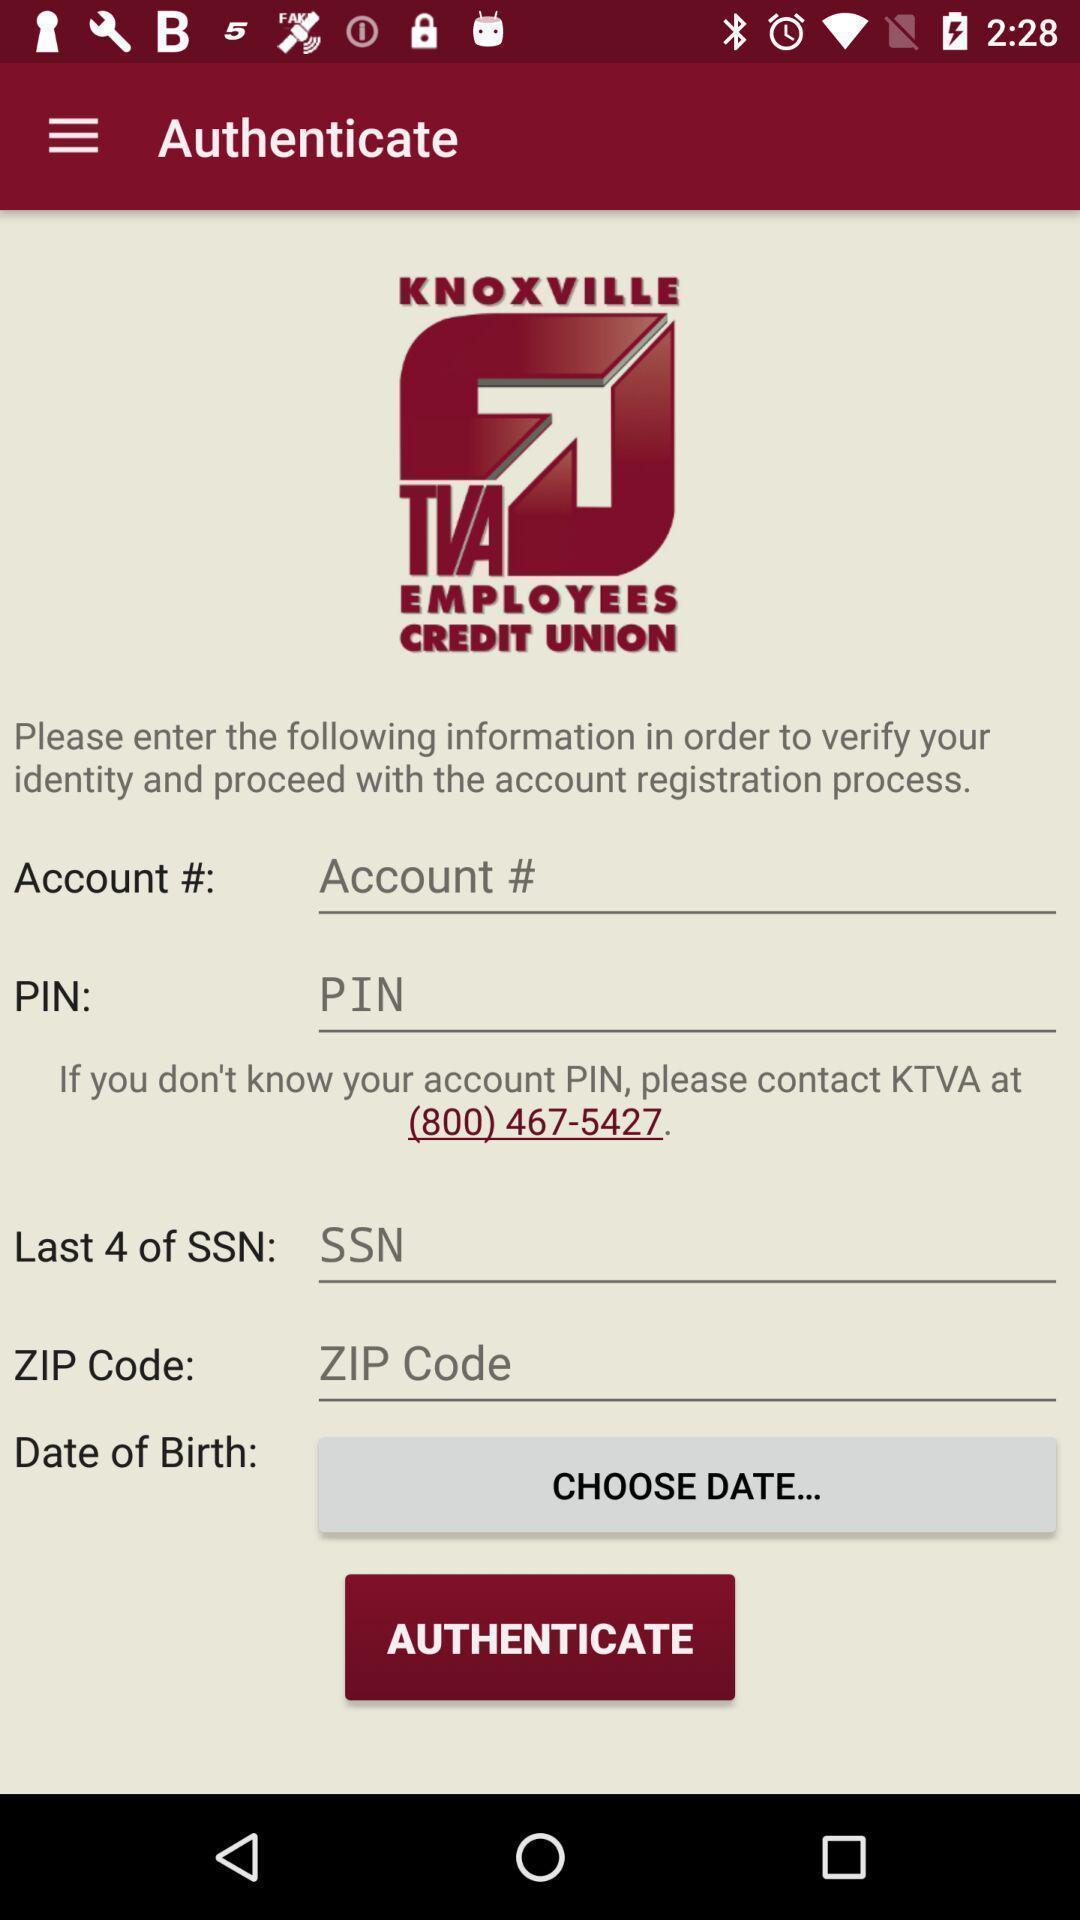Describe the content in this image. Screen shows authenticate details of a financial app. 